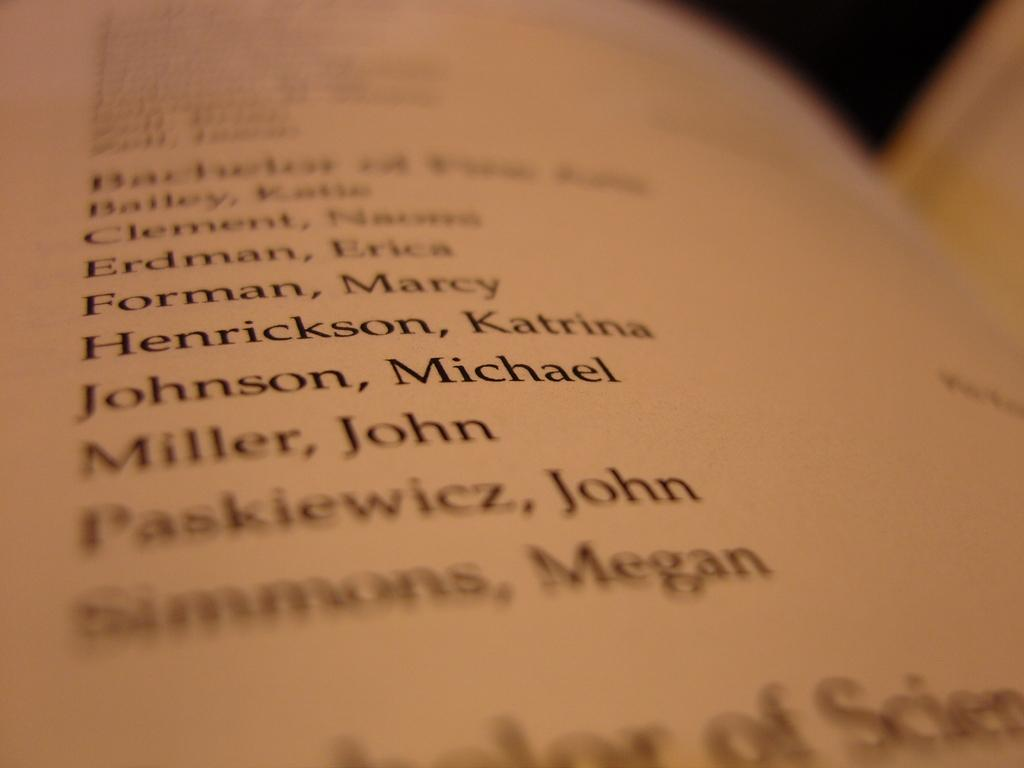Provide a one-sentence caption for the provided image. A list of names includes a female known as Marcy Forman. 